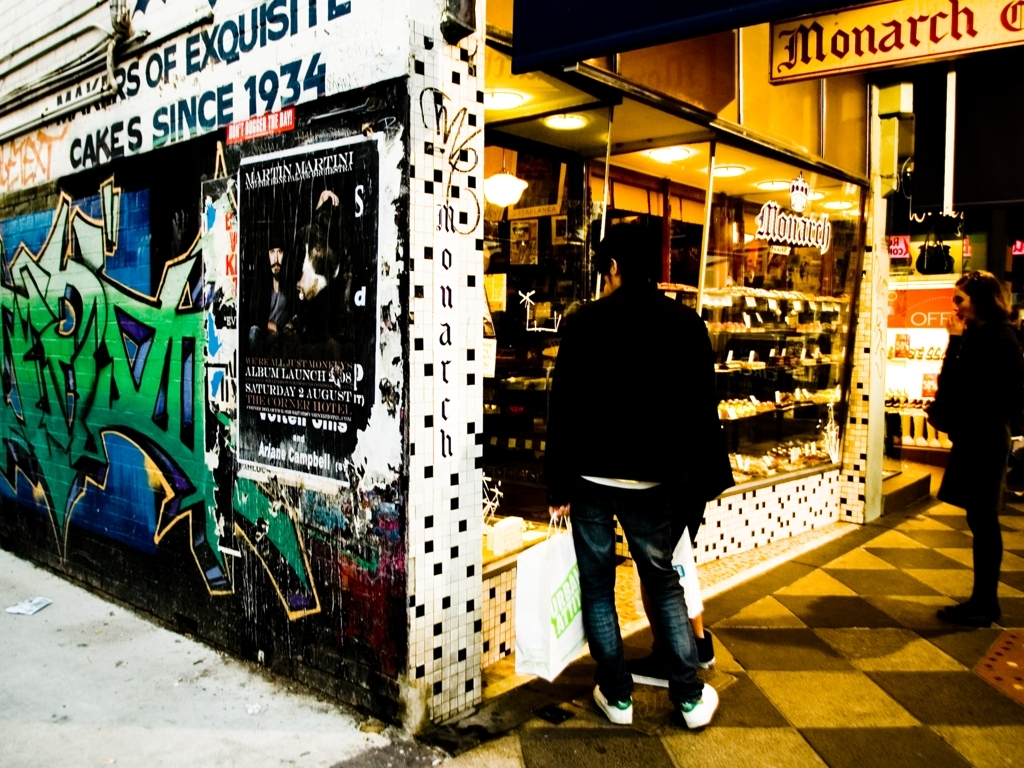What are some details that indicate the age of the building seen in the image? The building's age can be hinted at by the architectural details like the checkered pattern on its lower facade, which is reminiscent of styles from mid-20th century or earlier. The wear and tear visible on the walls and the faded posters also suggest that the building has a long-standing history. 